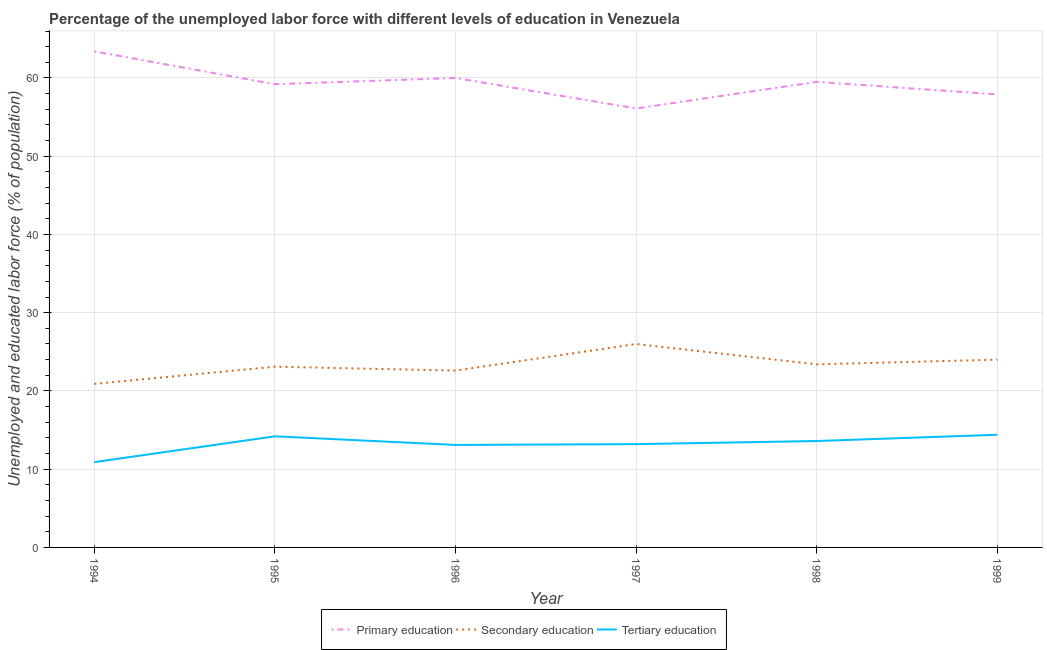How many different coloured lines are there?
Keep it short and to the point. 3. Does the line corresponding to percentage of labor force who received tertiary education intersect with the line corresponding to percentage of labor force who received primary education?
Offer a very short reply. No. What is the percentage of labor force who received secondary education in 1997?
Provide a succinct answer. 26. Across all years, what is the minimum percentage of labor force who received secondary education?
Give a very brief answer. 20.9. In which year was the percentage of labor force who received primary education maximum?
Provide a succinct answer. 1994. What is the total percentage of labor force who received tertiary education in the graph?
Make the answer very short. 79.4. What is the difference between the percentage of labor force who received secondary education in 1995 and the percentage of labor force who received tertiary education in 1999?
Ensure brevity in your answer.  8.7. What is the average percentage of labor force who received tertiary education per year?
Your response must be concise. 13.23. In the year 1996, what is the difference between the percentage of labor force who received secondary education and percentage of labor force who received tertiary education?
Ensure brevity in your answer.  9.5. What is the ratio of the percentage of labor force who received primary education in 1995 to that in 1996?
Your answer should be compact. 0.99. What is the difference between the highest and the second highest percentage of labor force who received tertiary education?
Keep it short and to the point. 0.2. In how many years, is the percentage of labor force who received secondary education greater than the average percentage of labor force who received secondary education taken over all years?
Provide a succinct answer. 3. Is the sum of the percentage of labor force who received primary education in 1994 and 1995 greater than the maximum percentage of labor force who received secondary education across all years?
Your answer should be very brief. Yes. Is it the case that in every year, the sum of the percentage of labor force who received primary education and percentage of labor force who received secondary education is greater than the percentage of labor force who received tertiary education?
Ensure brevity in your answer.  Yes. Is the percentage of labor force who received primary education strictly greater than the percentage of labor force who received tertiary education over the years?
Offer a very short reply. Yes. Is the percentage of labor force who received secondary education strictly less than the percentage of labor force who received tertiary education over the years?
Make the answer very short. No. How many lines are there?
Provide a succinct answer. 3. What is the difference between two consecutive major ticks on the Y-axis?
Keep it short and to the point. 10. Are the values on the major ticks of Y-axis written in scientific E-notation?
Provide a short and direct response. No. What is the title of the graph?
Your answer should be very brief. Percentage of the unemployed labor force with different levels of education in Venezuela. What is the label or title of the Y-axis?
Your answer should be very brief. Unemployed and educated labor force (% of population). What is the Unemployed and educated labor force (% of population) of Primary education in 1994?
Offer a very short reply. 63.4. What is the Unemployed and educated labor force (% of population) in Secondary education in 1994?
Keep it short and to the point. 20.9. What is the Unemployed and educated labor force (% of population) of Tertiary education in 1994?
Offer a terse response. 10.9. What is the Unemployed and educated labor force (% of population) of Primary education in 1995?
Offer a terse response. 59.2. What is the Unemployed and educated labor force (% of population) in Secondary education in 1995?
Provide a short and direct response. 23.1. What is the Unemployed and educated labor force (% of population) of Tertiary education in 1995?
Make the answer very short. 14.2. What is the Unemployed and educated labor force (% of population) of Secondary education in 1996?
Ensure brevity in your answer.  22.6. What is the Unemployed and educated labor force (% of population) of Tertiary education in 1996?
Your response must be concise. 13.1. What is the Unemployed and educated labor force (% of population) in Primary education in 1997?
Provide a succinct answer. 56.1. What is the Unemployed and educated labor force (% of population) in Tertiary education in 1997?
Your response must be concise. 13.2. What is the Unemployed and educated labor force (% of population) of Primary education in 1998?
Ensure brevity in your answer.  59.5. What is the Unemployed and educated labor force (% of population) in Secondary education in 1998?
Make the answer very short. 23.4. What is the Unemployed and educated labor force (% of population) in Tertiary education in 1998?
Offer a terse response. 13.6. What is the Unemployed and educated labor force (% of population) of Primary education in 1999?
Your answer should be compact. 57.9. What is the Unemployed and educated labor force (% of population) in Secondary education in 1999?
Your response must be concise. 24. What is the Unemployed and educated labor force (% of population) in Tertiary education in 1999?
Offer a very short reply. 14.4. Across all years, what is the maximum Unemployed and educated labor force (% of population) in Primary education?
Your response must be concise. 63.4. Across all years, what is the maximum Unemployed and educated labor force (% of population) in Secondary education?
Give a very brief answer. 26. Across all years, what is the maximum Unemployed and educated labor force (% of population) of Tertiary education?
Make the answer very short. 14.4. Across all years, what is the minimum Unemployed and educated labor force (% of population) of Primary education?
Ensure brevity in your answer.  56.1. Across all years, what is the minimum Unemployed and educated labor force (% of population) in Secondary education?
Offer a terse response. 20.9. Across all years, what is the minimum Unemployed and educated labor force (% of population) in Tertiary education?
Your answer should be very brief. 10.9. What is the total Unemployed and educated labor force (% of population) of Primary education in the graph?
Your answer should be compact. 356.1. What is the total Unemployed and educated labor force (% of population) in Secondary education in the graph?
Provide a succinct answer. 140. What is the total Unemployed and educated labor force (% of population) of Tertiary education in the graph?
Provide a succinct answer. 79.4. What is the difference between the Unemployed and educated labor force (% of population) in Primary education in 1994 and that in 1995?
Give a very brief answer. 4.2. What is the difference between the Unemployed and educated labor force (% of population) in Tertiary education in 1994 and that in 1995?
Your answer should be compact. -3.3. What is the difference between the Unemployed and educated labor force (% of population) of Primary education in 1994 and that in 1996?
Ensure brevity in your answer.  3.4. What is the difference between the Unemployed and educated labor force (% of population) of Primary education in 1994 and that in 1997?
Make the answer very short. 7.3. What is the difference between the Unemployed and educated labor force (% of population) in Tertiary education in 1994 and that in 1997?
Offer a very short reply. -2.3. What is the difference between the Unemployed and educated labor force (% of population) in Primary education in 1994 and that in 1998?
Give a very brief answer. 3.9. What is the difference between the Unemployed and educated labor force (% of population) in Secondary education in 1994 and that in 1998?
Offer a very short reply. -2.5. What is the difference between the Unemployed and educated labor force (% of population) in Tertiary education in 1994 and that in 1998?
Make the answer very short. -2.7. What is the difference between the Unemployed and educated labor force (% of population) of Secondary education in 1994 and that in 1999?
Give a very brief answer. -3.1. What is the difference between the Unemployed and educated labor force (% of population) of Primary education in 1995 and that in 1996?
Provide a short and direct response. -0.8. What is the difference between the Unemployed and educated labor force (% of population) in Secondary education in 1995 and that in 1996?
Give a very brief answer. 0.5. What is the difference between the Unemployed and educated labor force (% of population) in Tertiary education in 1995 and that in 1996?
Give a very brief answer. 1.1. What is the difference between the Unemployed and educated labor force (% of population) of Primary education in 1995 and that in 1997?
Provide a short and direct response. 3.1. What is the difference between the Unemployed and educated labor force (% of population) in Tertiary education in 1995 and that in 1997?
Your response must be concise. 1. What is the difference between the Unemployed and educated labor force (% of population) in Secondary education in 1995 and that in 1998?
Keep it short and to the point. -0.3. What is the difference between the Unemployed and educated labor force (% of population) in Primary education in 1995 and that in 1999?
Keep it short and to the point. 1.3. What is the difference between the Unemployed and educated labor force (% of population) of Secondary education in 1996 and that in 1997?
Offer a very short reply. -3.4. What is the difference between the Unemployed and educated labor force (% of population) of Tertiary education in 1996 and that in 1997?
Your answer should be compact. -0.1. What is the difference between the Unemployed and educated labor force (% of population) of Primary education in 1996 and that in 1998?
Keep it short and to the point. 0.5. What is the difference between the Unemployed and educated labor force (% of population) of Primary education in 1996 and that in 1999?
Offer a terse response. 2.1. What is the difference between the Unemployed and educated labor force (% of population) in Secondary education in 1996 and that in 1999?
Make the answer very short. -1.4. What is the difference between the Unemployed and educated labor force (% of population) in Tertiary education in 1996 and that in 1999?
Ensure brevity in your answer.  -1.3. What is the difference between the Unemployed and educated labor force (% of population) in Primary education in 1997 and that in 1998?
Ensure brevity in your answer.  -3.4. What is the difference between the Unemployed and educated labor force (% of population) in Secondary education in 1997 and that in 1998?
Offer a very short reply. 2.6. What is the difference between the Unemployed and educated labor force (% of population) of Primary education in 1997 and that in 1999?
Make the answer very short. -1.8. What is the difference between the Unemployed and educated labor force (% of population) of Secondary education in 1997 and that in 1999?
Your answer should be very brief. 2. What is the difference between the Unemployed and educated labor force (% of population) in Primary education in 1998 and that in 1999?
Provide a short and direct response. 1.6. What is the difference between the Unemployed and educated labor force (% of population) in Tertiary education in 1998 and that in 1999?
Provide a succinct answer. -0.8. What is the difference between the Unemployed and educated labor force (% of population) in Primary education in 1994 and the Unemployed and educated labor force (% of population) in Secondary education in 1995?
Offer a very short reply. 40.3. What is the difference between the Unemployed and educated labor force (% of population) of Primary education in 1994 and the Unemployed and educated labor force (% of population) of Tertiary education in 1995?
Offer a terse response. 49.2. What is the difference between the Unemployed and educated labor force (% of population) in Secondary education in 1994 and the Unemployed and educated labor force (% of population) in Tertiary education in 1995?
Keep it short and to the point. 6.7. What is the difference between the Unemployed and educated labor force (% of population) of Primary education in 1994 and the Unemployed and educated labor force (% of population) of Secondary education in 1996?
Ensure brevity in your answer.  40.8. What is the difference between the Unemployed and educated labor force (% of population) in Primary education in 1994 and the Unemployed and educated labor force (% of population) in Tertiary education in 1996?
Provide a succinct answer. 50.3. What is the difference between the Unemployed and educated labor force (% of population) in Secondary education in 1994 and the Unemployed and educated labor force (% of population) in Tertiary education in 1996?
Provide a succinct answer. 7.8. What is the difference between the Unemployed and educated labor force (% of population) of Primary education in 1994 and the Unemployed and educated labor force (% of population) of Secondary education in 1997?
Keep it short and to the point. 37.4. What is the difference between the Unemployed and educated labor force (% of population) in Primary education in 1994 and the Unemployed and educated labor force (% of population) in Tertiary education in 1997?
Provide a short and direct response. 50.2. What is the difference between the Unemployed and educated labor force (% of population) of Primary education in 1994 and the Unemployed and educated labor force (% of population) of Secondary education in 1998?
Make the answer very short. 40. What is the difference between the Unemployed and educated labor force (% of population) in Primary education in 1994 and the Unemployed and educated labor force (% of population) in Tertiary education in 1998?
Keep it short and to the point. 49.8. What is the difference between the Unemployed and educated labor force (% of population) in Secondary education in 1994 and the Unemployed and educated labor force (% of population) in Tertiary education in 1998?
Your answer should be compact. 7.3. What is the difference between the Unemployed and educated labor force (% of population) in Primary education in 1994 and the Unemployed and educated labor force (% of population) in Secondary education in 1999?
Keep it short and to the point. 39.4. What is the difference between the Unemployed and educated labor force (% of population) of Secondary education in 1994 and the Unemployed and educated labor force (% of population) of Tertiary education in 1999?
Make the answer very short. 6.5. What is the difference between the Unemployed and educated labor force (% of population) in Primary education in 1995 and the Unemployed and educated labor force (% of population) in Secondary education in 1996?
Your answer should be very brief. 36.6. What is the difference between the Unemployed and educated labor force (% of population) of Primary education in 1995 and the Unemployed and educated labor force (% of population) of Tertiary education in 1996?
Your response must be concise. 46.1. What is the difference between the Unemployed and educated labor force (% of population) of Secondary education in 1995 and the Unemployed and educated labor force (% of population) of Tertiary education in 1996?
Make the answer very short. 10. What is the difference between the Unemployed and educated labor force (% of population) of Primary education in 1995 and the Unemployed and educated labor force (% of population) of Secondary education in 1997?
Your answer should be compact. 33.2. What is the difference between the Unemployed and educated labor force (% of population) of Primary education in 1995 and the Unemployed and educated labor force (% of population) of Tertiary education in 1997?
Your response must be concise. 46. What is the difference between the Unemployed and educated labor force (% of population) of Primary education in 1995 and the Unemployed and educated labor force (% of population) of Secondary education in 1998?
Offer a very short reply. 35.8. What is the difference between the Unemployed and educated labor force (% of population) of Primary education in 1995 and the Unemployed and educated labor force (% of population) of Tertiary education in 1998?
Your response must be concise. 45.6. What is the difference between the Unemployed and educated labor force (% of population) in Primary education in 1995 and the Unemployed and educated labor force (% of population) in Secondary education in 1999?
Keep it short and to the point. 35.2. What is the difference between the Unemployed and educated labor force (% of population) in Primary education in 1995 and the Unemployed and educated labor force (% of population) in Tertiary education in 1999?
Your answer should be very brief. 44.8. What is the difference between the Unemployed and educated labor force (% of population) of Secondary education in 1995 and the Unemployed and educated labor force (% of population) of Tertiary education in 1999?
Provide a short and direct response. 8.7. What is the difference between the Unemployed and educated labor force (% of population) in Primary education in 1996 and the Unemployed and educated labor force (% of population) in Secondary education in 1997?
Provide a short and direct response. 34. What is the difference between the Unemployed and educated labor force (% of population) of Primary education in 1996 and the Unemployed and educated labor force (% of population) of Tertiary education in 1997?
Your answer should be compact. 46.8. What is the difference between the Unemployed and educated labor force (% of population) in Primary education in 1996 and the Unemployed and educated labor force (% of population) in Secondary education in 1998?
Provide a short and direct response. 36.6. What is the difference between the Unemployed and educated labor force (% of population) of Primary education in 1996 and the Unemployed and educated labor force (% of population) of Tertiary education in 1998?
Make the answer very short. 46.4. What is the difference between the Unemployed and educated labor force (% of population) of Primary education in 1996 and the Unemployed and educated labor force (% of population) of Tertiary education in 1999?
Provide a short and direct response. 45.6. What is the difference between the Unemployed and educated labor force (% of population) in Primary education in 1997 and the Unemployed and educated labor force (% of population) in Secondary education in 1998?
Ensure brevity in your answer.  32.7. What is the difference between the Unemployed and educated labor force (% of population) of Primary education in 1997 and the Unemployed and educated labor force (% of population) of Tertiary education in 1998?
Keep it short and to the point. 42.5. What is the difference between the Unemployed and educated labor force (% of population) in Primary education in 1997 and the Unemployed and educated labor force (% of population) in Secondary education in 1999?
Make the answer very short. 32.1. What is the difference between the Unemployed and educated labor force (% of population) in Primary education in 1997 and the Unemployed and educated labor force (% of population) in Tertiary education in 1999?
Your answer should be compact. 41.7. What is the difference between the Unemployed and educated labor force (% of population) of Primary education in 1998 and the Unemployed and educated labor force (% of population) of Secondary education in 1999?
Keep it short and to the point. 35.5. What is the difference between the Unemployed and educated labor force (% of population) in Primary education in 1998 and the Unemployed and educated labor force (% of population) in Tertiary education in 1999?
Offer a terse response. 45.1. What is the average Unemployed and educated labor force (% of population) in Primary education per year?
Offer a terse response. 59.35. What is the average Unemployed and educated labor force (% of population) of Secondary education per year?
Ensure brevity in your answer.  23.33. What is the average Unemployed and educated labor force (% of population) of Tertiary education per year?
Your response must be concise. 13.23. In the year 1994, what is the difference between the Unemployed and educated labor force (% of population) in Primary education and Unemployed and educated labor force (% of population) in Secondary education?
Keep it short and to the point. 42.5. In the year 1994, what is the difference between the Unemployed and educated labor force (% of population) in Primary education and Unemployed and educated labor force (% of population) in Tertiary education?
Offer a very short reply. 52.5. In the year 1995, what is the difference between the Unemployed and educated labor force (% of population) of Primary education and Unemployed and educated labor force (% of population) of Secondary education?
Provide a succinct answer. 36.1. In the year 1995, what is the difference between the Unemployed and educated labor force (% of population) in Secondary education and Unemployed and educated labor force (% of population) in Tertiary education?
Provide a succinct answer. 8.9. In the year 1996, what is the difference between the Unemployed and educated labor force (% of population) in Primary education and Unemployed and educated labor force (% of population) in Secondary education?
Provide a short and direct response. 37.4. In the year 1996, what is the difference between the Unemployed and educated labor force (% of population) of Primary education and Unemployed and educated labor force (% of population) of Tertiary education?
Provide a succinct answer. 46.9. In the year 1996, what is the difference between the Unemployed and educated labor force (% of population) of Secondary education and Unemployed and educated labor force (% of population) of Tertiary education?
Provide a succinct answer. 9.5. In the year 1997, what is the difference between the Unemployed and educated labor force (% of population) in Primary education and Unemployed and educated labor force (% of population) in Secondary education?
Your answer should be very brief. 30.1. In the year 1997, what is the difference between the Unemployed and educated labor force (% of population) in Primary education and Unemployed and educated labor force (% of population) in Tertiary education?
Ensure brevity in your answer.  42.9. In the year 1997, what is the difference between the Unemployed and educated labor force (% of population) in Secondary education and Unemployed and educated labor force (% of population) in Tertiary education?
Your answer should be very brief. 12.8. In the year 1998, what is the difference between the Unemployed and educated labor force (% of population) in Primary education and Unemployed and educated labor force (% of population) in Secondary education?
Give a very brief answer. 36.1. In the year 1998, what is the difference between the Unemployed and educated labor force (% of population) of Primary education and Unemployed and educated labor force (% of population) of Tertiary education?
Your response must be concise. 45.9. In the year 1999, what is the difference between the Unemployed and educated labor force (% of population) in Primary education and Unemployed and educated labor force (% of population) in Secondary education?
Your answer should be very brief. 33.9. In the year 1999, what is the difference between the Unemployed and educated labor force (% of population) in Primary education and Unemployed and educated labor force (% of population) in Tertiary education?
Give a very brief answer. 43.5. In the year 1999, what is the difference between the Unemployed and educated labor force (% of population) of Secondary education and Unemployed and educated labor force (% of population) of Tertiary education?
Ensure brevity in your answer.  9.6. What is the ratio of the Unemployed and educated labor force (% of population) in Primary education in 1994 to that in 1995?
Provide a short and direct response. 1.07. What is the ratio of the Unemployed and educated labor force (% of population) of Secondary education in 1994 to that in 1995?
Offer a terse response. 0.9. What is the ratio of the Unemployed and educated labor force (% of population) in Tertiary education in 1994 to that in 1995?
Offer a very short reply. 0.77. What is the ratio of the Unemployed and educated labor force (% of population) in Primary education in 1994 to that in 1996?
Provide a short and direct response. 1.06. What is the ratio of the Unemployed and educated labor force (% of population) of Secondary education in 1994 to that in 1996?
Offer a very short reply. 0.92. What is the ratio of the Unemployed and educated labor force (% of population) of Tertiary education in 1994 to that in 1996?
Provide a short and direct response. 0.83. What is the ratio of the Unemployed and educated labor force (% of population) in Primary education in 1994 to that in 1997?
Provide a short and direct response. 1.13. What is the ratio of the Unemployed and educated labor force (% of population) of Secondary education in 1994 to that in 1997?
Provide a succinct answer. 0.8. What is the ratio of the Unemployed and educated labor force (% of population) of Tertiary education in 1994 to that in 1997?
Ensure brevity in your answer.  0.83. What is the ratio of the Unemployed and educated labor force (% of population) in Primary education in 1994 to that in 1998?
Your response must be concise. 1.07. What is the ratio of the Unemployed and educated labor force (% of population) in Secondary education in 1994 to that in 1998?
Keep it short and to the point. 0.89. What is the ratio of the Unemployed and educated labor force (% of population) of Tertiary education in 1994 to that in 1998?
Make the answer very short. 0.8. What is the ratio of the Unemployed and educated labor force (% of population) of Primary education in 1994 to that in 1999?
Provide a short and direct response. 1.09. What is the ratio of the Unemployed and educated labor force (% of population) in Secondary education in 1994 to that in 1999?
Offer a terse response. 0.87. What is the ratio of the Unemployed and educated labor force (% of population) in Tertiary education in 1994 to that in 1999?
Your response must be concise. 0.76. What is the ratio of the Unemployed and educated labor force (% of population) of Primary education in 1995 to that in 1996?
Give a very brief answer. 0.99. What is the ratio of the Unemployed and educated labor force (% of population) in Secondary education in 1995 to that in 1996?
Keep it short and to the point. 1.02. What is the ratio of the Unemployed and educated labor force (% of population) of Tertiary education in 1995 to that in 1996?
Your answer should be compact. 1.08. What is the ratio of the Unemployed and educated labor force (% of population) of Primary education in 1995 to that in 1997?
Your answer should be very brief. 1.06. What is the ratio of the Unemployed and educated labor force (% of population) of Secondary education in 1995 to that in 1997?
Your answer should be compact. 0.89. What is the ratio of the Unemployed and educated labor force (% of population) of Tertiary education in 1995 to that in 1997?
Provide a short and direct response. 1.08. What is the ratio of the Unemployed and educated labor force (% of population) of Primary education in 1995 to that in 1998?
Your answer should be compact. 0.99. What is the ratio of the Unemployed and educated labor force (% of population) in Secondary education in 1995 to that in 1998?
Ensure brevity in your answer.  0.99. What is the ratio of the Unemployed and educated labor force (% of population) in Tertiary education in 1995 to that in 1998?
Your response must be concise. 1.04. What is the ratio of the Unemployed and educated labor force (% of population) in Primary education in 1995 to that in 1999?
Your answer should be very brief. 1.02. What is the ratio of the Unemployed and educated labor force (% of population) in Secondary education in 1995 to that in 1999?
Your answer should be compact. 0.96. What is the ratio of the Unemployed and educated labor force (% of population) of Tertiary education in 1995 to that in 1999?
Provide a succinct answer. 0.99. What is the ratio of the Unemployed and educated labor force (% of population) in Primary education in 1996 to that in 1997?
Your response must be concise. 1.07. What is the ratio of the Unemployed and educated labor force (% of population) of Secondary education in 1996 to that in 1997?
Your response must be concise. 0.87. What is the ratio of the Unemployed and educated labor force (% of population) of Tertiary education in 1996 to that in 1997?
Your response must be concise. 0.99. What is the ratio of the Unemployed and educated labor force (% of population) in Primary education in 1996 to that in 1998?
Provide a short and direct response. 1.01. What is the ratio of the Unemployed and educated labor force (% of population) of Secondary education in 1996 to that in 1998?
Give a very brief answer. 0.97. What is the ratio of the Unemployed and educated labor force (% of population) of Tertiary education in 1996 to that in 1998?
Your answer should be very brief. 0.96. What is the ratio of the Unemployed and educated labor force (% of population) in Primary education in 1996 to that in 1999?
Keep it short and to the point. 1.04. What is the ratio of the Unemployed and educated labor force (% of population) of Secondary education in 1996 to that in 1999?
Give a very brief answer. 0.94. What is the ratio of the Unemployed and educated labor force (% of population) in Tertiary education in 1996 to that in 1999?
Your response must be concise. 0.91. What is the ratio of the Unemployed and educated labor force (% of population) of Primary education in 1997 to that in 1998?
Ensure brevity in your answer.  0.94. What is the ratio of the Unemployed and educated labor force (% of population) of Secondary education in 1997 to that in 1998?
Your answer should be compact. 1.11. What is the ratio of the Unemployed and educated labor force (% of population) of Tertiary education in 1997 to that in 1998?
Offer a very short reply. 0.97. What is the ratio of the Unemployed and educated labor force (% of population) of Primary education in 1997 to that in 1999?
Your answer should be compact. 0.97. What is the ratio of the Unemployed and educated labor force (% of population) in Tertiary education in 1997 to that in 1999?
Provide a short and direct response. 0.92. What is the ratio of the Unemployed and educated labor force (% of population) in Primary education in 1998 to that in 1999?
Your answer should be very brief. 1.03. What is the difference between the highest and the second highest Unemployed and educated labor force (% of population) of Secondary education?
Keep it short and to the point. 2. What is the difference between the highest and the second highest Unemployed and educated labor force (% of population) of Tertiary education?
Offer a terse response. 0.2. 